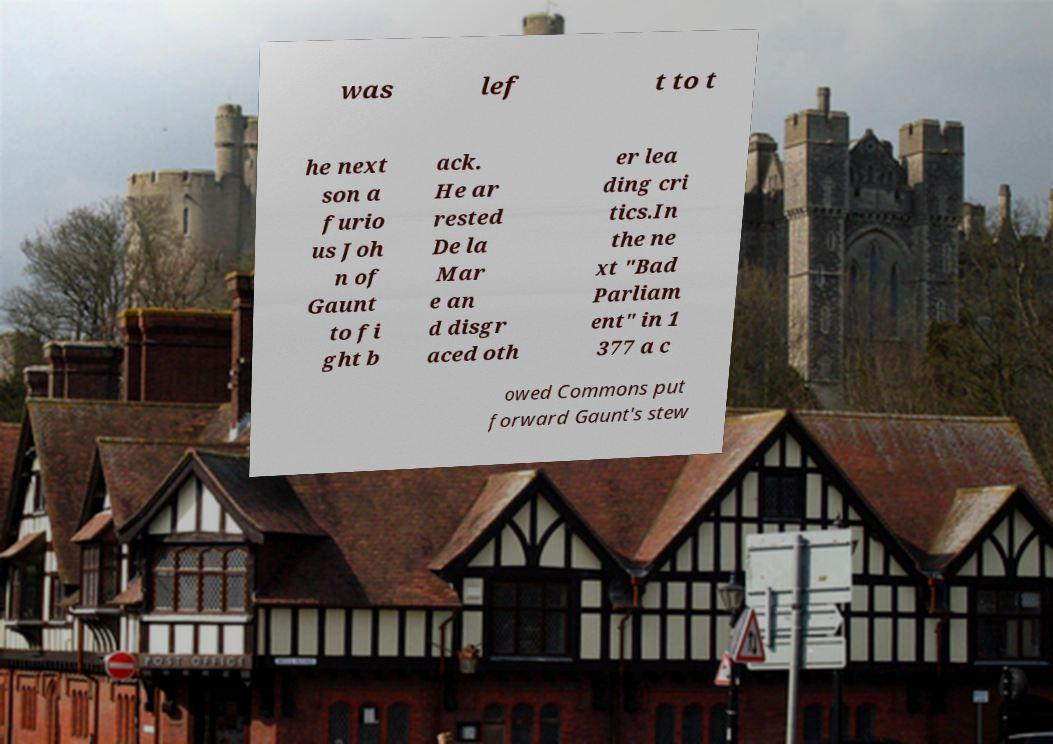I need the written content from this picture converted into text. Can you do that? was lef t to t he next son a furio us Joh n of Gaunt to fi ght b ack. He ar rested De la Mar e an d disgr aced oth er lea ding cri tics.In the ne xt "Bad Parliam ent" in 1 377 a c owed Commons put forward Gaunt's stew 